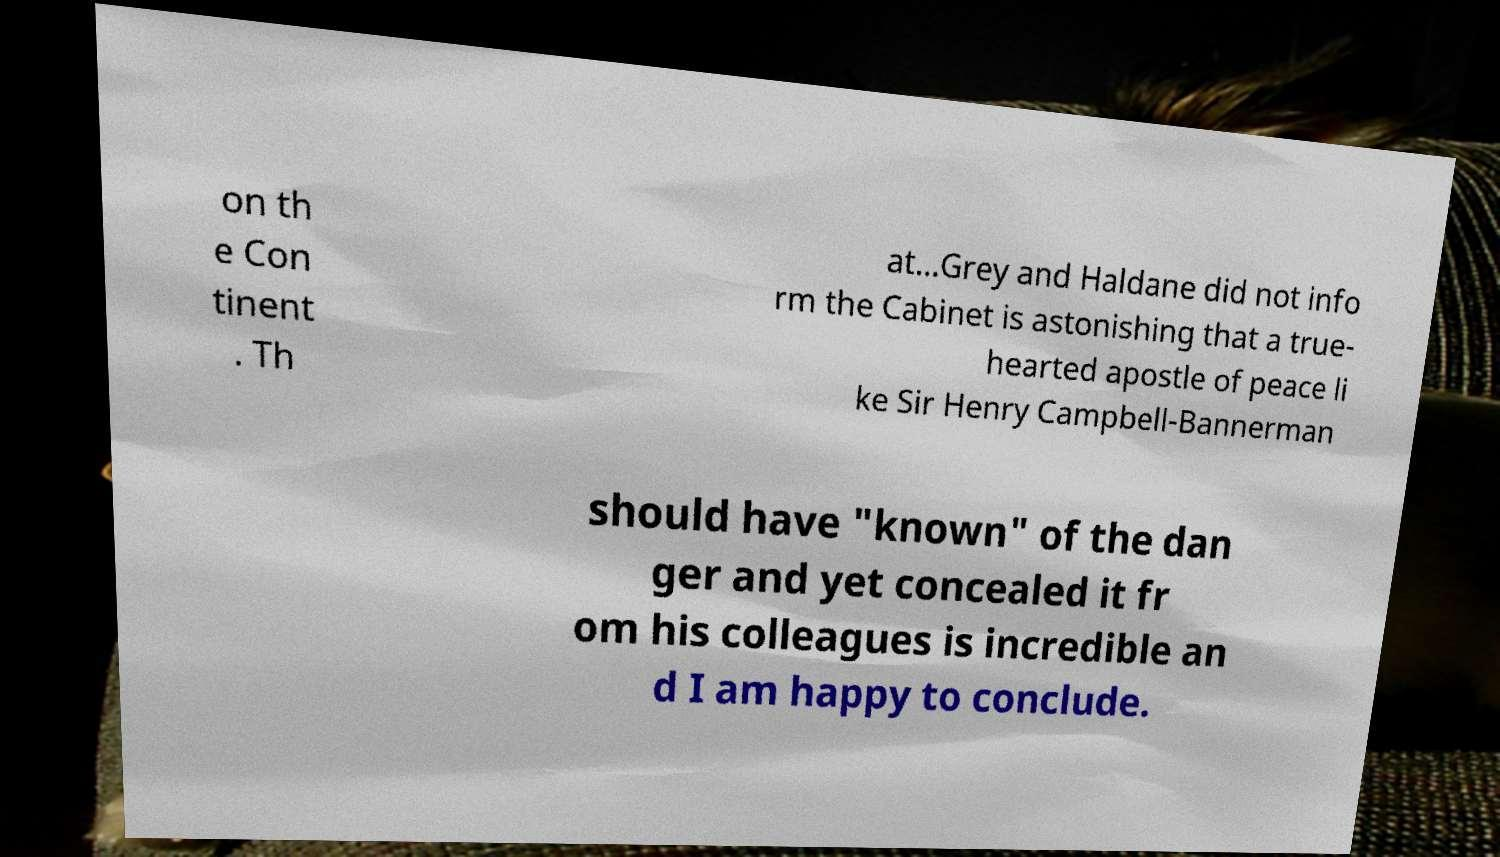There's text embedded in this image that I need extracted. Can you transcribe it verbatim? on th e Con tinent . Th at...Grey and Haldane did not info rm the Cabinet is astonishing that a true- hearted apostle of peace li ke Sir Henry Campbell-Bannerman should have "known" of the dan ger and yet concealed it fr om his colleagues is incredible an d I am happy to conclude. 